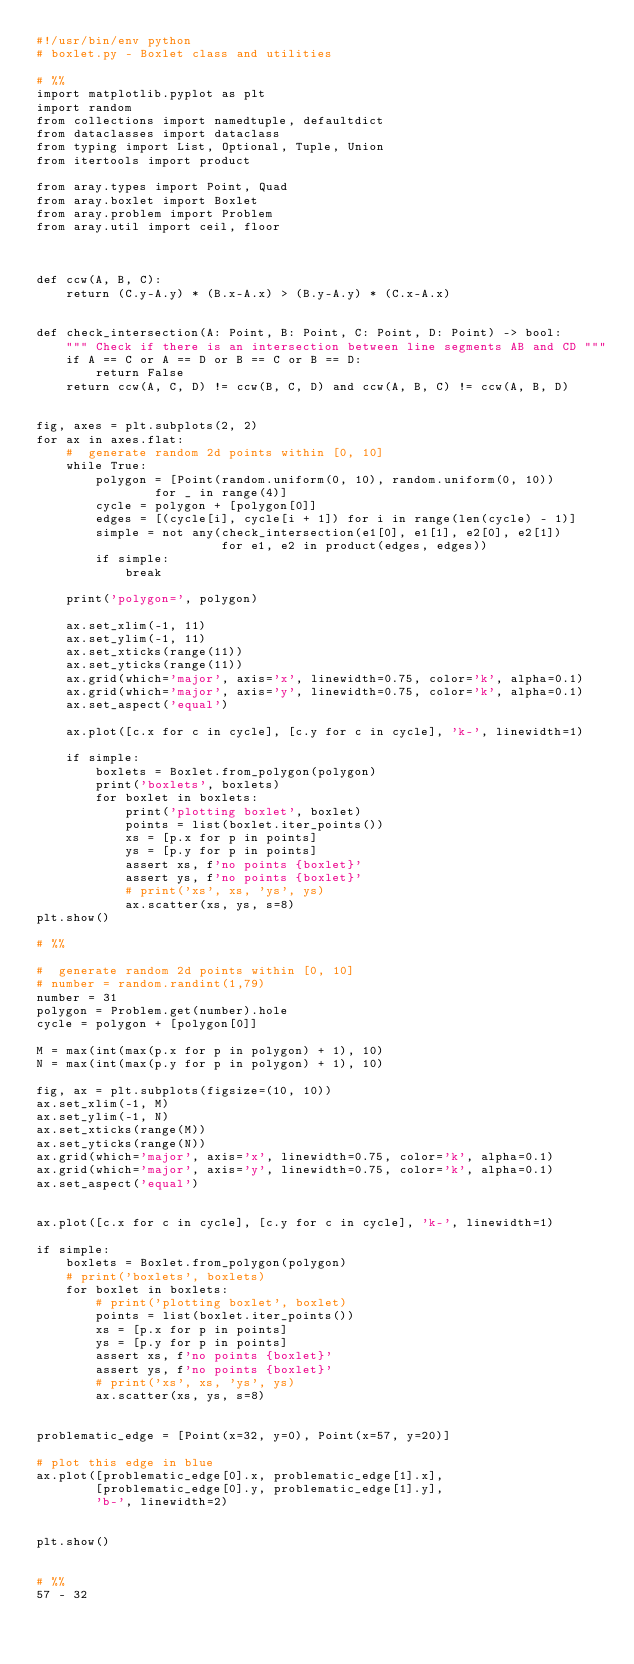Convert code to text. <code><loc_0><loc_0><loc_500><loc_500><_Python_>#!/usr/bin/env python
# boxlet.py - Boxlet class and utilities

# %%
import matplotlib.pyplot as plt
import random
from collections import namedtuple, defaultdict
from dataclasses import dataclass
from typing import List, Optional, Tuple, Union
from itertools import product

from aray.types import Point, Quad
from aray.boxlet import Boxlet
from aray.problem import Problem
from aray.util import ceil, floor



def ccw(A, B, C):
    return (C.y-A.y) * (B.x-A.x) > (B.y-A.y) * (C.x-A.x)


def check_intersection(A: Point, B: Point, C: Point, D: Point) -> bool:
    """ Check if there is an intersection between line segments AB and CD """
    if A == C or A == D or B == C or B == D:
        return False
    return ccw(A, C, D) != ccw(B, C, D) and ccw(A, B, C) != ccw(A, B, D)


fig, axes = plt.subplots(2, 2)
for ax in axes.flat:
    #  generate random 2d points within [0, 10]
    while True:
        polygon = [Point(random.uniform(0, 10), random.uniform(0, 10))
                for _ in range(4)]
        cycle = polygon + [polygon[0]]
        edges = [(cycle[i], cycle[i + 1]) for i in range(len(cycle) - 1)]
        simple = not any(check_intersection(e1[0], e1[1], e2[0], e2[1])
                         for e1, e2 in product(edges, edges))
        if simple:
            break

    print('polygon=', polygon)

    ax.set_xlim(-1, 11)
    ax.set_ylim(-1, 11)
    ax.set_xticks(range(11))
    ax.set_yticks(range(11))
    ax.grid(which='major', axis='x', linewidth=0.75, color='k', alpha=0.1)
    ax.grid(which='major', axis='y', linewidth=0.75, color='k', alpha=0.1)
    ax.set_aspect('equal')

    ax.plot([c.x for c in cycle], [c.y for c in cycle], 'k-', linewidth=1)

    if simple:
        boxlets = Boxlet.from_polygon(polygon)
        print('boxlets', boxlets)
        for boxlet in boxlets:
            print('plotting boxlet', boxlet)
            points = list(boxlet.iter_points())
            xs = [p.x for p in points]
            ys = [p.y for p in points]
            assert xs, f'no points {boxlet}'
            assert ys, f'no points {boxlet}'
            # print('xs', xs, 'ys', ys)
            ax.scatter(xs, ys, s=8)
plt.show()

# %%

#  generate random 2d points within [0, 10]
# number = random.randint(1,79)
number = 31
polygon = Problem.get(number).hole
cycle = polygon + [polygon[0]]

M = max(int(max(p.x for p in polygon) + 1), 10)
N = max(int(max(p.y for p in polygon) + 1), 10)

fig, ax = plt.subplots(figsize=(10, 10))
ax.set_xlim(-1, M)
ax.set_ylim(-1, N)
ax.set_xticks(range(M))
ax.set_yticks(range(N))
ax.grid(which='major', axis='x', linewidth=0.75, color='k', alpha=0.1)
ax.grid(which='major', axis='y', linewidth=0.75, color='k', alpha=0.1)
ax.set_aspect('equal')


ax.plot([c.x for c in cycle], [c.y for c in cycle], 'k-', linewidth=1)

if simple:
    boxlets = Boxlet.from_polygon(polygon)
    # print('boxlets', boxlets)
    for boxlet in boxlets:
        # print('plotting boxlet', boxlet)
        points = list(boxlet.iter_points())
        xs = [p.x for p in points]
        ys = [p.y for p in points]
        assert xs, f'no points {boxlet}'
        assert ys, f'no points {boxlet}'
        # print('xs', xs, 'ys', ys)
        ax.scatter(xs, ys, s=8)


problematic_edge = [Point(x=32, y=0), Point(x=57, y=20)]

# plot this edge in blue
ax.plot([problematic_edge[0].x, problematic_edge[1].x],
        [problematic_edge[0].y, problematic_edge[1].y],
        'b-', linewidth=2)


plt.show()


# %%
57 - 32</code> 